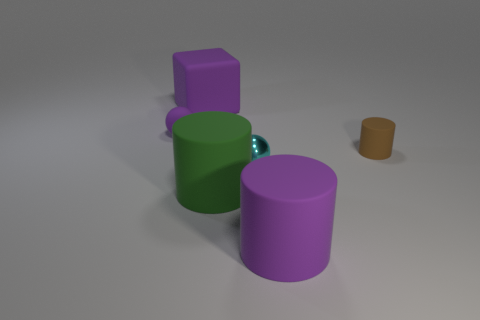What number of metallic things are small red cylinders or purple blocks?
Ensure brevity in your answer.  0. Are there any large purple things that are in front of the small matte thing that is to the right of the large purple rubber cylinder?
Offer a terse response. Yes. Are the big cylinder that is left of the big purple matte cylinder and the cyan thing made of the same material?
Offer a terse response. No. What number of other objects are there of the same color as the tiny rubber cylinder?
Your answer should be very brief. 0. Is the color of the tiny matte sphere the same as the cube?
Ensure brevity in your answer.  Yes. How big is the purple matte thing that is behind the tiny ball that is behind the brown cylinder?
Your answer should be compact. Large. Does the purple thing that is to the right of the block have the same material as the ball that is to the right of the large cube?
Give a very brief answer. No. There is a tiny matte object that is on the left side of the big rubber cube; does it have the same color as the rubber cube?
Give a very brief answer. Yes. There is a cyan metallic ball; how many large purple matte objects are on the left side of it?
Keep it short and to the point. 1. Is the material of the tiny purple object the same as the sphere in front of the small purple rubber thing?
Ensure brevity in your answer.  No. 